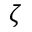Convert formula to latex. <formula><loc_0><loc_0><loc_500><loc_500>\zeta</formula> 